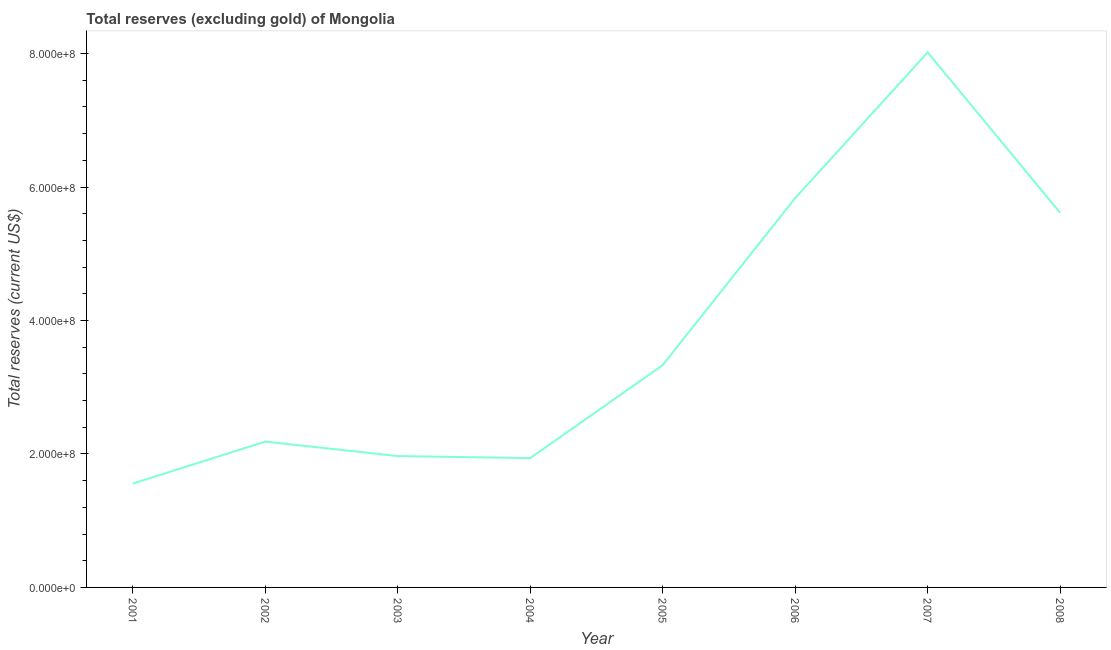What is the total reserves (excluding gold) in 2001?
Offer a terse response. 1.56e+08. Across all years, what is the maximum total reserves (excluding gold)?
Provide a short and direct response. 8.02e+08. Across all years, what is the minimum total reserves (excluding gold)?
Offer a very short reply. 1.56e+08. In which year was the total reserves (excluding gold) maximum?
Make the answer very short. 2007. In which year was the total reserves (excluding gold) minimum?
Your answer should be very brief. 2001. What is the sum of the total reserves (excluding gold)?
Offer a terse response. 3.04e+09. What is the difference between the total reserves (excluding gold) in 2001 and 2006?
Give a very brief answer. -4.28e+08. What is the average total reserves (excluding gold) per year?
Offer a very short reply. 3.81e+08. What is the median total reserves (excluding gold)?
Your answer should be compact. 2.76e+08. Do a majority of the years between 2004 and 2005 (inclusive) have total reserves (excluding gold) greater than 440000000 US$?
Provide a succinct answer. No. What is the ratio of the total reserves (excluding gold) in 2003 to that in 2006?
Your answer should be very brief. 0.34. Is the total reserves (excluding gold) in 2003 less than that in 2008?
Your answer should be compact. Yes. Is the difference between the total reserves (excluding gold) in 2004 and 2005 greater than the difference between any two years?
Keep it short and to the point. No. What is the difference between the highest and the second highest total reserves (excluding gold)?
Keep it short and to the point. 2.18e+08. Is the sum of the total reserves (excluding gold) in 2001 and 2003 greater than the maximum total reserves (excluding gold) across all years?
Offer a very short reply. No. What is the difference between the highest and the lowest total reserves (excluding gold)?
Offer a very short reply. 6.46e+08. In how many years, is the total reserves (excluding gold) greater than the average total reserves (excluding gold) taken over all years?
Ensure brevity in your answer.  3. Does the total reserves (excluding gold) monotonically increase over the years?
Provide a succinct answer. No. What is the difference between two consecutive major ticks on the Y-axis?
Your answer should be compact. 2.00e+08. Are the values on the major ticks of Y-axis written in scientific E-notation?
Offer a very short reply. Yes. Does the graph contain grids?
Your answer should be compact. No. What is the title of the graph?
Make the answer very short. Total reserves (excluding gold) of Mongolia. What is the label or title of the X-axis?
Your response must be concise. Year. What is the label or title of the Y-axis?
Your answer should be compact. Total reserves (current US$). What is the Total reserves (current US$) in 2001?
Keep it short and to the point. 1.56e+08. What is the Total reserves (current US$) in 2002?
Make the answer very short. 2.19e+08. What is the Total reserves (current US$) in 2003?
Make the answer very short. 1.97e+08. What is the Total reserves (current US$) of 2004?
Provide a succinct answer. 1.94e+08. What is the Total reserves (current US$) of 2005?
Offer a very short reply. 3.33e+08. What is the Total reserves (current US$) in 2006?
Provide a short and direct response. 5.83e+08. What is the Total reserves (current US$) of 2007?
Give a very brief answer. 8.02e+08. What is the Total reserves (current US$) of 2008?
Your answer should be very brief. 5.61e+08. What is the difference between the Total reserves (current US$) in 2001 and 2002?
Offer a terse response. -6.29e+07. What is the difference between the Total reserves (current US$) in 2001 and 2003?
Ensure brevity in your answer.  -4.13e+07. What is the difference between the Total reserves (current US$) in 2001 and 2004?
Your response must be concise. -3.81e+07. What is the difference between the Total reserves (current US$) in 2001 and 2005?
Provide a short and direct response. -1.78e+08. What is the difference between the Total reserves (current US$) in 2001 and 2006?
Keep it short and to the point. -4.28e+08. What is the difference between the Total reserves (current US$) in 2001 and 2007?
Give a very brief answer. -6.46e+08. What is the difference between the Total reserves (current US$) in 2001 and 2008?
Make the answer very short. -4.06e+08. What is the difference between the Total reserves (current US$) in 2002 and 2003?
Offer a terse response. 2.16e+07. What is the difference between the Total reserves (current US$) in 2002 and 2004?
Keep it short and to the point. 2.48e+07. What is the difference between the Total reserves (current US$) in 2002 and 2005?
Ensure brevity in your answer.  -1.15e+08. What is the difference between the Total reserves (current US$) in 2002 and 2006?
Keep it short and to the point. -3.65e+08. What is the difference between the Total reserves (current US$) in 2002 and 2007?
Your answer should be compact. -5.83e+08. What is the difference between the Total reserves (current US$) in 2002 and 2008?
Provide a succinct answer. -3.43e+08. What is the difference between the Total reserves (current US$) in 2003 and 2004?
Provide a succinct answer. 3.14e+06. What is the difference between the Total reserves (current US$) in 2003 and 2005?
Keep it short and to the point. -1.36e+08. What is the difference between the Total reserves (current US$) in 2003 and 2006?
Ensure brevity in your answer.  -3.87e+08. What is the difference between the Total reserves (current US$) in 2003 and 2007?
Offer a terse response. -6.05e+08. What is the difference between the Total reserves (current US$) in 2003 and 2008?
Provide a short and direct response. -3.65e+08. What is the difference between the Total reserves (current US$) in 2004 and 2005?
Ensure brevity in your answer.  -1.39e+08. What is the difference between the Total reserves (current US$) in 2004 and 2006?
Provide a succinct answer. -3.90e+08. What is the difference between the Total reserves (current US$) in 2004 and 2007?
Provide a short and direct response. -6.08e+08. What is the difference between the Total reserves (current US$) in 2004 and 2008?
Provide a short and direct response. -3.68e+08. What is the difference between the Total reserves (current US$) in 2005 and 2006?
Your answer should be very brief. -2.50e+08. What is the difference between the Total reserves (current US$) in 2005 and 2007?
Keep it short and to the point. -4.69e+08. What is the difference between the Total reserves (current US$) in 2005 and 2008?
Your response must be concise. -2.28e+08. What is the difference between the Total reserves (current US$) in 2006 and 2007?
Offer a very short reply. -2.18e+08. What is the difference between the Total reserves (current US$) in 2006 and 2008?
Make the answer very short. 2.19e+07. What is the difference between the Total reserves (current US$) in 2007 and 2008?
Give a very brief answer. 2.40e+08. What is the ratio of the Total reserves (current US$) in 2001 to that in 2002?
Provide a short and direct response. 0.71. What is the ratio of the Total reserves (current US$) in 2001 to that in 2003?
Your answer should be compact. 0.79. What is the ratio of the Total reserves (current US$) in 2001 to that in 2004?
Ensure brevity in your answer.  0.8. What is the ratio of the Total reserves (current US$) in 2001 to that in 2005?
Your answer should be compact. 0.47. What is the ratio of the Total reserves (current US$) in 2001 to that in 2006?
Your response must be concise. 0.27. What is the ratio of the Total reserves (current US$) in 2001 to that in 2007?
Your answer should be compact. 0.19. What is the ratio of the Total reserves (current US$) in 2001 to that in 2008?
Your answer should be very brief. 0.28. What is the ratio of the Total reserves (current US$) in 2002 to that in 2003?
Keep it short and to the point. 1.11. What is the ratio of the Total reserves (current US$) in 2002 to that in 2004?
Provide a short and direct response. 1.13. What is the ratio of the Total reserves (current US$) in 2002 to that in 2005?
Ensure brevity in your answer.  0.66. What is the ratio of the Total reserves (current US$) in 2002 to that in 2006?
Provide a succinct answer. 0.38. What is the ratio of the Total reserves (current US$) in 2002 to that in 2007?
Give a very brief answer. 0.27. What is the ratio of the Total reserves (current US$) in 2002 to that in 2008?
Your answer should be very brief. 0.39. What is the ratio of the Total reserves (current US$) in 2003 to that in 2004?
Your answer should be compact. 1.02. What is the ratio of the Total reserves (current US$) in 2003 to that in 2005?
Your response must be concise. 0.59. What is the ratio of the Total reserves (current US$) in 2003 to that in 2006?
Make the answer very short. 0.34. What is the ratio of the Total reserves (current US$) in 2003 to that in 2007?
Provide a succinct answer. 0.25. What is the ratio of the Total reserves (current US$) in 2003 to that in 2008?
Provide a succinct answer. 0.35. What is the ratio of the Total reserves (current US$) in 2004 to that in 2005?
Give a very brief answer. 0.58. What is the ratio of the Total reserves (current US$) in 2004 to that in 2006?
Your answer should be very brief. 0.33. What is the ratio of the Total reserves (current US$) in 2004 to that in 2007?
Keep it short and to the point. 0.24. What is the ratio of the Total reserves (current US$) in 2004 to that in 2008?
Your response must be concise. 0.34. What is the ratio of the Total reserves (current US$) in 2005 to that in 2006?
Give a very brief answer. 0.57. What is the ratio of the Total reserves (current US$) in 2005 to that in 2007?
Your response must be concise. 0.42. What is the ratio of the Total reserves (current US$) in 2005 to that in 2008?
Make the answer very short. 0.59. What is the ratio of the Total reserves (current US$) in 2006 to that in 2007?
Make the answer very short. 0.73. What is the ratio of the Total reserves (current US$) in 2006 to that in 2008?
Your answer should be very brief. 1.04. What is the ratio of the Total reserves (current US$) in 2007 to that in 2008?
Your answer should be very brief. 1.43. 